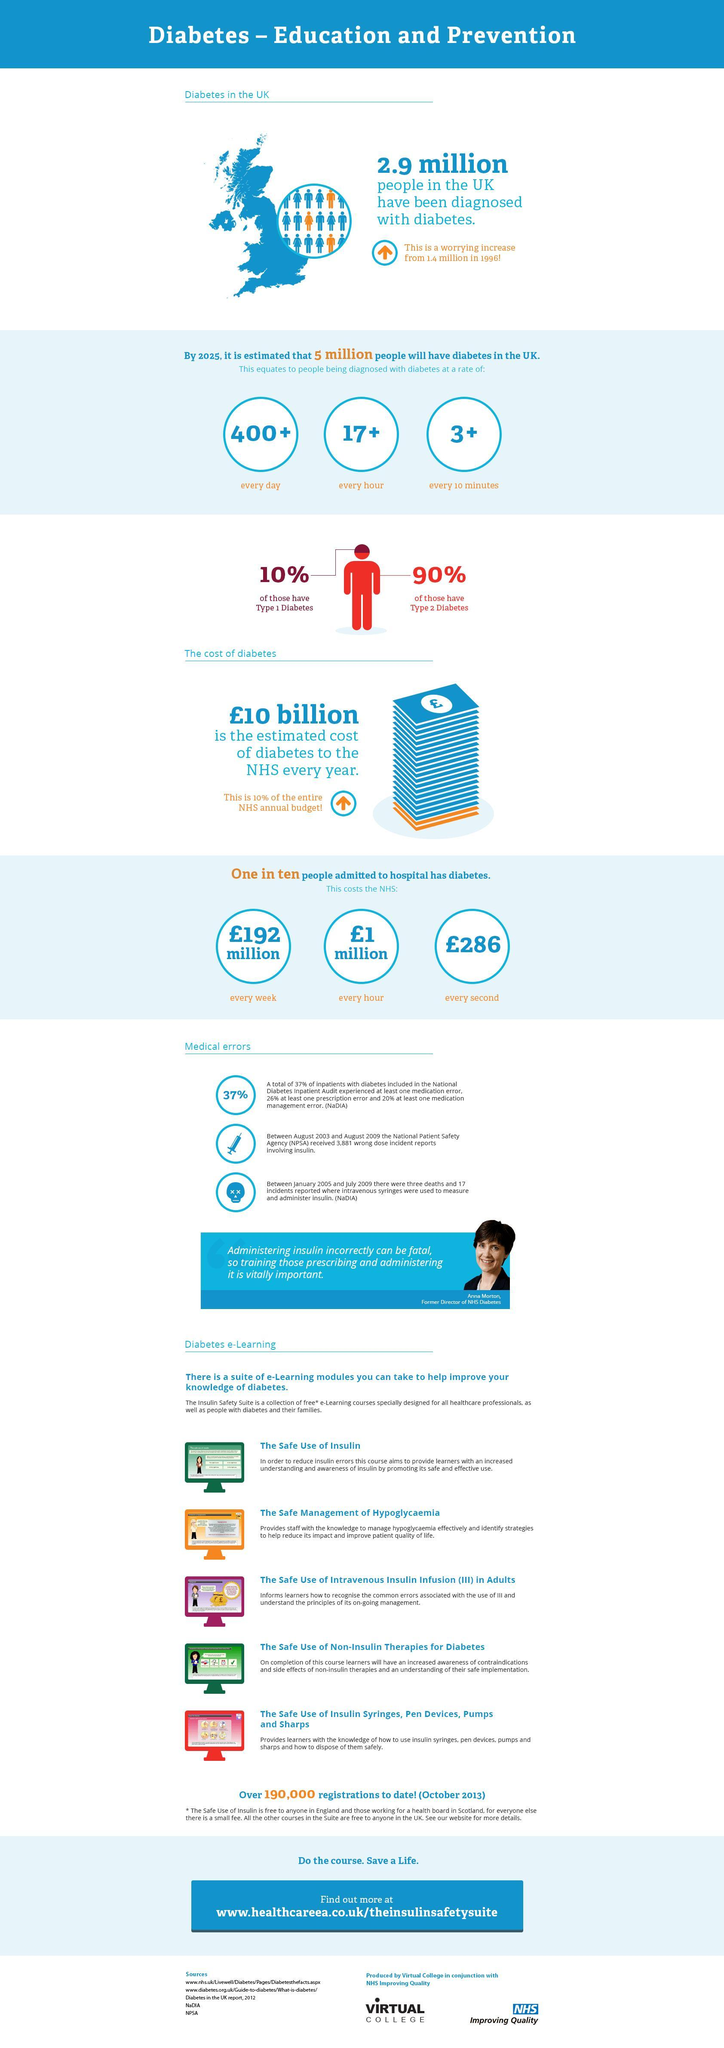How many people among 10 admitted in UK hospitals are not Diabetic?
Answer the question with a short phrase. 9 How much is the increase in number of people (in millions) with diabetes from 1996 to present? 1.5 What is the cost (in pounds) to NHS due to the hospital admission of Asthma patients for every second? 286 How much is the calculated cost (in pounds) to NHS due to the hospital admission of Asthma patients for an hour? 1 million How many people in UK are diagnosed with Type 1 Diabetes? 10% According to the statistics how many civilians in UK will be affected with diabetes each day? 400+ According to the statistics how many people will be diagnosed with diabetes every hour? 17+ According to the statistics how many people will be diagnosed with diabetes every 10 minutes? 3+ What percentage of people in UK are diagnosed with Type 2 Diabetes? 90% What is the cost (in pounds) to NHS due to the hospital admission of Asthma patients for a week? 192 million 